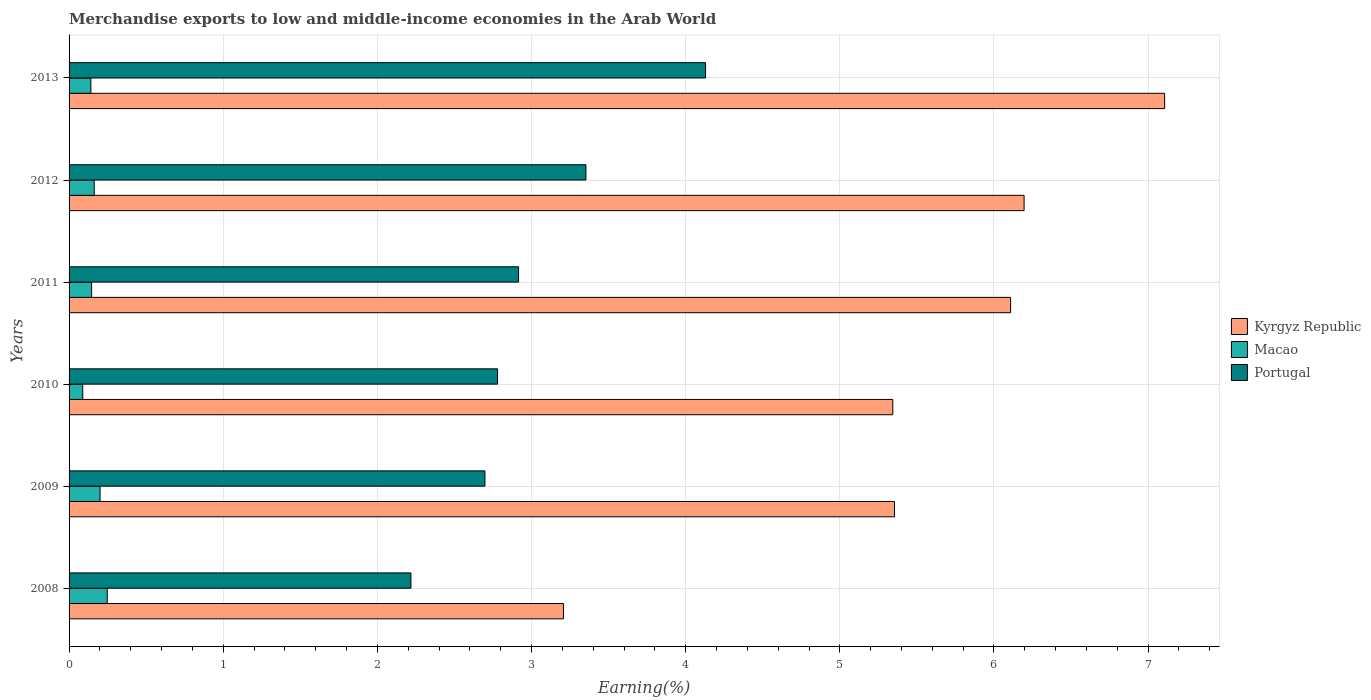How many different coloured bars are there?
Your answer should be compact. 3. How many groups of bars are there?
Keep it short and to the point. 6. Are the number of bars per tick equal to the number of legend labels?
Provide a short and direct response. Yes. Are the number of bars on each tick of the Y-axis equal?
Provide a short and direct response. Yes. How many bars are there on the 5th tick from the top?
Give a very brief answer. 3. How many bars are there on the 4th tick from the bottom?
Provide a succinct answer. 3. What is the label of the 3rd group of bars from the top?
Give a very brief answer. 2011. What is the percentage of amount earned from merchandise exports in Macao in 2008?
Ensure brevity in your answer.  0.25. Across all years, what is the maximum percentage of amount earned from merchandise exports in Macao?
Your answer should be very brief. 0.25. Across all years, what is the minimum percentage of amount earned from merchandise exports in Kyrgyz Republic?
Offer a terse response. 3.21. In which year was the percentage of amount earned from merchandise exports in Portugal maximum?
Give a very brief answer. 2013. What is the total percentage of amount earned from merchandise exports in Kyrgyz Republic in the graph?
Provide a succinct answer. 33.32. What is the difference between the percentage of amount earned from merchandise exports in Portugal in 2008 and that in 2011?
Give a very brief answer. -0.7. What is the difference between the percentage of amount earned from merchandise exports in Kyrgyz Republic in 2010 and the percentage of amount earned from merchandise exports in Portugal in 2009?
Keep it short and to the point. 2.65. What is the average percentage of amount earned from merchandise exports in Macao per year?
Offer a very short reply. 0.16. In the year 2013, what is the difference between the percentage of amount earned from merchandise exports in Macao and percentage of amount earned from merchandise exports in Kyrgyz Republic?
Provide a short and direct response. -6.97. In how many years, is the percentage of amount earned from merchandise exports in Macao greater than 4.6 %?
Your answer should be very brief. 0. What is the ratio of the percentage of amount earned from merchandise exports in Macao in 2011 to that in 2012?
Keep it short and to the point. 0.9. Is the percentage of amount earned from merchandise exports in Kyrgyz Republic in 2010 less than that in 2012?
Offer a terse response. Yes. What is the difference between the highest and the second highest percentage of amount earned from merchandise exports in Macao?
Offer a terse response. 0.05. What is the difference between the highest and the lowest percentage of amount earned from merchandise exports in Macao?
Keep it short and to the point. 0.16. In how many years, is the percentage of amount earned from merchandise exports in Macao greater than the average percentage of amount earned from merchandise exports in Macao taken over all years?
Offer a terse response. 2. What does the 1st bar from the top in 2010 represents?
Make the answer very short. Portugal. Is it the case that in every year, the sum of the percentage of amount earned from merchandise exports in Portugal and percentage of amount earned from merchandise exports in Kyrgyz Republic is greater than the percentage of amount earned from merchandise exports in Macao?
Ensure brevity in your answer.  Yes. How many bars are there?
Offer a very short reply. 18. Are all the bars in the graph horizontal?
Your answer should be very brief. Yes. How many years are there in the graph?
Your response must be concise. 6. Does the graph contain any zero values?
Your response must be concise. No. Does the graph contain grids?
Your answer should be very brief. Yes. Where does the legend appear in the graph?
Offer a terse response. Center right. How many legend labels are there?
Your answer should be compact. 3. What is the title of the graph?
Offer a terse response. Merchandise exports to low and middle-income economies in the Arab World. What is the label or title of the X-axis?
Provide a short and direct response. Earning(%). What is the label or title of the Y-axis?
Your answer should be compact. Years. What is the Earning(%) of Kyrgyz Republic in 2008?
Provide a succinct answer. 3.21. What is the Earning(%) of Macao in 2008?
Offer a very short reply. 0.25. What is the Earning(%) of Portugal in 2008?
Provide a short and direct response. 2.22. What is the Earning(%) in Kyrgyz Republic in 2009?
Ensure brevity in your answer.  5.35. What is the Earning(%) of Macao in 2009?
Provide a succinct answer. 0.2. What is the Earning(%) in Portugal in 2009?
Ensure brevity in your answer.  2.7. What is the Earning(%) of Kyrgyz Republic in 2010?
Your answer should be very brief. 5.34. What is the Earning(%) of Macao in 2010?
Provide a succinct answer. 0.09. What is the Earning(%) of Portugal in 2010?
Your answer should be very brief. 2.78. What is the Earning(%) in Kyrgyz Republic in 2011?
Your answer should be very brief. 6.11. What is the Earning(%) of Macao in 2011?
Your answer should be compact. 0.15. What is the Earning(%) in Portugal in 2011?
Give a very brief answer. 2.92. What is the Earning(%) in Kyrgyz Republic in 2012?
Provide a succinct answer. 6.2. What is the Earning(%) of Macao in 2012?
Ensure brevity in your answer.  0.16. What is the Earning(%) in Portugal in 2012?
Offer a terse response. 3.35. What is the Earning(%) of Kyrgyz Republic in 2013?
Offer a very short reply. 7.11. What is the Earning(%) in Macao in 2013?
Make the answer very short. 0.14. What is the Earning(%) in Portugal in 2013?
Provide a short and direct response. 4.13. Across all years, what is the maximum Earning(%) of Kyrgyz Republic?
Your answer should be compact. 7.11. Across all years, what is the maximum Earning(%) in Macao?
Provide a short and direct response. 0.25. Across all years, what is the maximum Earning(%) in Portugal?
Keep it short and to the point. 4.13. Across all years, what is the minimum Earning(%) in Kyrgyz Republic?
Ensure brevity in your answer.  3.21. Across all years, what is the minimum Earning(%) of Macao?
Give a very brief answer. 0.09. Across all years, what is the minimum Earning(%) of Portugal?
Offer a terse response. 2.22. What is the total Earning(%) in Kyrgyz Republic in the graph?
Offer a terse response. 33.32. What is the total Earning(%) in Macao in the graph?
Make the answer very short. 0.99. What is the total Earning(%) in Portugal in the graph?
Your response must be concise. 18.09. What is the difference between the Earning(%) of Kyrgyz Republic in 2008 and that in 2009?
Give a very brief answer. -2.15. What is the difference between the Earning(%) of Macao in 2008 and that in 2009?
Provide a short and direct response. 0.05. What is the difference between the Earning(%) in Portugal in 2008 and that in 2009?
Ensure brevity in your answer.  -0.48. What is the difference between the Earning(%) in Kyrgyz Republic in 2008 and that in 2010?
Your answer should be compact. -2.14. What is the difference between the Earning(%) in Macao in 2008 and that in 2010?
Make the answer very short. 0.16. What is the difference between the Earning(%) of Portugal in 2008 and that in 2010?
Make the answer very short. -0.56. What is the difference between the Earning(%) of Kyrgyz Republic in 2008 and that in 2011?
Offer a very short reply. -2.9. What is the difference between the Earning(%) in Macao in 2008 and that in 2011?
Your answer should be very brief. 0.1. What is the difference between the Earning(%) of Portugal in 2008 and that in 2011?
Provide a short and direct response. -0.7. What is the difference between the Earning(%) of Kyrgyz Republic in 2008 and that in 2012?
Offer a very short reply. -2.99. What is the difference between the Earning(%) in Macao in 2008 and that in 2012?
Offer a very short reply. 0.08. What is the difference between the Earning(%) in Portugal in 2008 and that in 2012?
Provide a short and direct response. -1.14. What is the difference between the Earning(%) in Kyrgyz Republic in 2008 and that in 2013?
Your response must be concise. -3.9. What is the difference between the Earning(%) of Macao in 2008 and that in 2013?
Keep it short and to the point. 0.11. What is the difference between the Earning(%) in Portugal in 2008 and that in 2013?
Provide a succinct answer. -1.91. What is the difference between the Earning(%) of Kyrgyz Republic in 2009 and that in 2010?
Your answer should be compact. 0.01. What is the difference between the Earning(%) in Macao in 2009 and that in 2010?
Ensure brevity in your answer.  0.11. What is the difference between the Earning(%) of Portugal in 2009 and that in 2010?
Offer a very short reply. -0.08. What is the difference between the Earning(%) of Kyrgyz Republic in 2009 and that in 2011?
Provide a short and direct response. -0.75. What is the difference between the Earning(%) in Macao in 2009 and that in 2011?
Ensure brevity in your answer.  0.05. What is the difference between the Earning(%) in Portugal in 2009 and that in 2011?
Ensure brevity in your answer.  -0.22. What is the difference between the Earning(%) of Kyrgyz Republic in 2009 and that in 2012?
Ensure brevity in your answer.  -0.84. What is the difference between the Earning(%) of Macao in 2009 and that in 2012?
Provide a short and direct response. 0.04. What is the difference between the Earning(%) in Portugal in 2009 and that in 2012?
Provide a succinct answer. -0.66. What is the difference between the Earning(%) in Kyrgyz Republic in 2009 and that in 2013?
Your response must be concise. -1.75. What is the difference between the Earning(%) in Macao in 2009 and that in 2013?
Your answer should be compact. 0.06. What is the difference between the Earning(%) in Portugal in 2009 and that in 2013?
Offer a terse response. -1.43. What is the difference between the Earning(%) in Kyrgyz Republic in 2010 and that in 2011?
Your answer should be compact. -0.76. What is the difference between the Earning(%) in Macao in 2010 and that in 2011?
Offer a very short reply. -0.06. What is the difference between the Earning(%) of Portugal in 2010 and that in 2011?
Make the answer very short. -0.14. What is the difference between the Earning(%) in Kyrgyz Republic in 2010 and that in 2012?
Make the answer very short. -0.85. What is the difference between the Earning(%) of Macao in 2010 and that in 2012?
Provide a short and direct response. -0.07. What is the difference between the Earning(%) in Portugal in 2010 and that in 2012?
Ensure brevity in your answer.  -0.57. What is the difference between the Earning(%) in Kyrgyz Republic in 2010 and that in 2013?
Your response must be concise. -1.76. What is the difference between the Earning(%) in Macao in 2010 and that in 2013?
Provide a short and direct response. -0.05. What is the difference between the Earning(%) in Portugal in 2010 and that in 2013?
Keep it short and to the point. -1.35. What is the difference between the Earning(%) of Kyrgyz Republic in 2011 and that in 2012?
Your response must be concise. -0.09. What is the difference between the Earning(%) in Macao in 2011 and that in 2012?
Your response must be concise. -0.02. What is the difference between the Earning(%) in Portugal in 2011 and that in 2012?
Provide a succinct answer. -0.44. What is the difference between the Earning(%) of Kyrgyz Republic in 2011 and that in 2013?
Make the answer very short. -1. What is the difference between the Earning(%) of Macao in 2011 and that in 2013?
Make the answer very short. 0. What is the difference between the Earning(%) of Portugal in 2011 and that in 2013?
Your answer should be very brief. -1.21. What is the difference between the Earning(%) of Kyrgyz Republic in 2012 and that in 2013?
Your response must be concise. -0.91. What is the difference between the Earning(%) of Macao in 2012 and that in 2013?
Your answer should be compact. 0.02. What is the difference between the Earning(%) of Portugal in 2012 and that in 2013?
Make the answer very short. -0.78. What is the difference between the Earning(%) of Kyrgyz Republic in 2008 and the Earning(%) of Macao in 2009?
Your answer should be compact. 3.01. What is the difference between the Earning(%) in Kyrgyz Republic in 2008 and the Earning(%) in Portugal in 2009?
Provide a succinct answer. 0.51. What is the difference between the Earning(%) in Macao in 2008 and the Earning(%) in Portugal in 2009?
Provide a succinct answer. -2.45. What is the difference between the Earning(%) in Kyrgyz Republic in 2008 and the Earning(%) in Macao in 2010?
Ensure brevity in your answer.  3.12. What is the difference between the Earning(%) in Kyrgyz Republic in 2008 and the Earning(%) in Portugal in 2010?
Provide a succinct answer. 0.43. What is the difference between the Earning(%) of Macao in 2008 and the Earning(%) of Portugal in 2010?
Give a very brief answer. -2.53. What is the difference between the Earning(%) in Kyrgyz Republic in 2008 and the Earning(%) in Macao in 2011?
Provide a short and direct response. 3.06. What is the difference between the Earning(%) of Kyrgyz Republic in 2008 and the Earning(%) of Portugal in 2011?
Your answer should be very brief. 0.29. What is the difference between the Earning(%) of Macao in 2008 and the Earning(%) of Portugal in 2011?
Provide a short and direct response. -2.67. What is the difference between the Earning(%) of Kyrgyz Republic in 2008 and the Earning(%) of Macao in 2012?
Offer a very short reply. 3.04. What is the difference between the Earning(%) in Kyrgyz Republic in 2008 and the Earning(%) in Portugal in 2012?
Offer a very short reply. -0.15. What is the difference between the Earning(%) of Macao in 2008 and the Earning(%) of Portugal in 2012?
Your response must be concise. -3.11. What is the difference between the Earning(%) in Kyrgyz Republic in 2008 and the Earning(%) in Macao in 2013?
Give a very brief answer. 3.07. What is the difference between the Earning(%) in Kyrgyz Republic in 2008 and the Earning(%) in Portugal in 2013?
Provide a short and direct response. -0.92. What is the difference between the Earning(%) of Macao in 2008 and the Earning(%) of Portugal in 2013?
Your response must be concise. -3.88. What is the difference between the Earning(%) of Kyrgyz Republic in 2009 and the Earning(%) of Macao in 2010?
Offer a terse response. 5.27. What is the difference between the Earning(%) of Kyrgyz Republic in 2009 and the Earning(%) of Portugal in 2010?
Ensure brevity in your answer.  2.58. What is the difference between the Earning(%) in Macao in 2009 and the Earning(%) in Portugal in 2010?
Ensure brevity in your answer.  -2.58. What is the difference between the Earning(%) of Kyrgyz Republic in 2009 and the Earning(%) of Macao in 2011?
Keep it short and to the point. 5.21. What is the difference between the Earning(%) of Kyrgyz Republic in 2009 and the Earning(%) of Portugal in 2011?
Your answer should be very brief. 2.44. What is the difference between the Earning(%) of Macao in 2009 and the Earning(%) of Portugal in 2011?
Your response must be concise. -2.71. What is the difference between the Earning(%) of Kyrgyz Republic in 2009 and the Earning(%) of Macao in 2012?
Your response must be concise. 5.19. What is the difference between the Earning(%) in Kyrgyz Republic in 2009 and the Earning(%) in Portugal in 2012?
Ensure brevity in your answer.  2. What is the difference between the Earning(%) in Macao in 2009 and the Earning(%) in Portugal in 2012?
Offer a terse response. -3.15. What is the difference between the Earning(%) of Kyrgyz Republic in 2009 and the Earning(%) of Macao in 2013?
Make the answer very short. 5.21. What is the difference between the Earning(%) in Kyrgyz Republic in 2009 and the Earning(%) in Portugal in 2013?
Make the answer very short. 1.23. What is the difference between the Earning(%) in Macao in 2009 and the Earning(%) in Portugal in 2013?
Offer a very short reply. -3.93. What is the difference between the Earning(%) of Kyrgyz Republic in 2010 and the Earning(%) of Macao in 2011?
Provide a short and direct response. 5.2. What is the difference between the Earning(%) of Kyrgyz Republic in 2010 and the Earning(%) of Portugal in 2011?
Offer a very short reply. 2.43. What is the difference between the Earning(%) in Macao in 2010 and the Earning(%) in Portugal in 2011?
Ensure brevity in your answer.  -2.83. What is the difference between the Earning(%) in Kyrgyz Republic in 2010 and the Earning(%) in Macao in 2012?
Ensure brevity in your answer.  5.18. What is the difference between the Earning(%) of Kyrgyz Republic in 2010 and the Earning(%) of Portugal in 2012?
Provide a succinct answer. 1.99. What is the difference between the Earning(%) of Macao in 2010 and the Earning(%) of Portugal in 2012?
Offer a very short reply. -3.26. What is the difference between the Earning(%) in Kyrgyz Republic in 2010 and the Earning(%) in Macao in 2013?
Provide a short and direct response. 5.2. What is the difference between the Earning(%) of Kyrgyz Republic in 2010 and the Earning(%) of Portugal in 2013?
Your answer should be very brief. 1.21. What is the difference between the Earning(%) in Macao in 2010 and the Earning(%) in Portugal in 2013?
Ensure brevity in your answer.  -4.04. What is the difference between the Earning(%) in Kyrgyz Republic in 2011 and the Earning(%) in Macao in 2012?
Offer a terse response. 5.94. What is the difference between the Earning(%) in Kyrgyz Republic in 2011 and the Earning(%) in Portugal in 2012?
Offer a very short reply. 2.75. What is the difference between the Earning(%) of Macao in 2011 and the Earning(%) of Portugal in 2012?
Make the answer very short. -3.21. What is the difference between the Earning(%) in Kyrgyz Republic in 2011 and the Earning(%) in Macao in 2013?
Provide a short and direct response. 5.97. What is the difference between the Earning(%) in Kyrgyz Republic in 2011 and the Earning(%) in Portugal in 2013?
Provide a succinct answer. 1.98. What is the difference between the Earning(%) of Macao in 2011 and the Earning(%) of Portugal in 2013?
Offer a very short reply. -3.98. What is the difference between the Earning(%) of Kyrgyz Republic in 2012 and the Earning(%) of Macao in 2013?
Keep it short and to the point. 6.05. What is the difference between the Earning(%) of Kyrgyz Republic in 2012 and the Earning(%) of Portugal in 2013?
Ensure brevity in your answer.  2.07. What is the difference between the Earning(%) in Macao in 2012 and the Earning(%) in Portugal in 2013?
Offer a terse response. -3.97. What is the average Earning(%) of Kyrgyz Republic per year?
Keep it short and to the point. 5.55. What is the average Earning(%) in Macao per year?
Your response must be concise. 0.16. What is the average Earning(%) of Portugal per year?
Offer a very short reply. 3.02. In the year 2008, what is the difference between the Earning(%) of Kyrgyz Republic and Earning(%) of Macao?
Your response must be concise. 2.96. In the year 2008, what is the difference between the Earning(%) in Kyrgyz Republic and Earning(%) in Portugal?
Give a very brief answer. 0.99. In the year 2008, what is the difference between the Earning(%) of Macao and Earning(%) of Portugal?
Offer a very short reply. -1.97. In the year 2009, what is the difference between the Earning(%) of Kyrgyz Republic and Earning(%) of Macao?
Your response must be concise. 5.15. In the year 2009, what is the difference between the Earning(%) of Kyrgyz Republic and Earning(%) of Portugal?
Provide a short and direct response. 2.66. In the year 2009, what is the difference between the Earning(%) of Macao and Earning(%) of Portugal?
Offer a very short reply. -2.5. In the year 2010, what is the difference between the Earning(%) of Kyrgyz Republic and Earning(%) of Macao?
Provide a succinct answer. 5.25. In the year 2010, what is the difference between the Earning(%) in Kyrgyz Republic and Earning(%) in Portugal?
Ensure brevity in your answer.  2.56. In the year 2010, what is the difference between the Earning(%) in Macao and Earning(%) in Portugal?
Provide a succinct answer. -2.69. In the year 2011, what is the difference between the Earning(%) of Kyrgyz Republic and Earning(%) of Macao?
Provide a short and direct response. 5.96. In the year 2011, what is the difference between the Earning(%) in Kyrgyz Republic and Earning(%) in Portugal?
Offer a very short reply. 3.19. In the year 2011, what is the difference between the Earning(%) in Macao and Earning(%) in Portugal?
Provide a short and direct response. -2.77. In the year 2012, what is the difference between the Earning(%) of Kyrgyz Republic and Earning(%) of Macao?
Give a very brief answer. 6.03. In the year 2012, what is the difference between the Earning(%) of Kyrgyz Republic and Earning(%) of Portugal?
Offer a terse response. 2.84. In the year 2012, what is the difference between the Earning(%) of Macao and Earning(%) of Portugal?
Offer a very short reply. -3.19. In the year 2013, what is the difference between the Earning(%) of Kyrgyz Republic and Earning(%) of Macao?
Your response must be concise. 6.97. In the year 2013, what is the difference between the Earning(%) of Kyrgyz Republic and Earning(%) of Portugal?
Keep it short and to the point. 2.98. In the year 2013, what is the difference between the Earning(%) of Macao and Earning(%) of Portugal?
Make the answer very short. -3.99. What is the ratio of the Earning(%) in Kyrgyz Republic in 2008 to that in 2009?
Provide a succinct answer. 0.6. What is the ratio of the Earning(%) in Macao in 2008 to that in 2009?
Give a very brief answer. 1.23. What is the ratio of the Earning(%) in Portugal in 2008 to that in 2009?
Your answer should be very brief. 0.82. What is the ratio of the Earning(%) in Kyrgyz Republic in 2008 to that in 2010?
Your answer should be compact. 0.6. What is the ratio of the Earning(%) of Macao in 2008 to that in 2010?
Your answer should be very brief. 2.79. What is the ratio of the Earning(%) in Portugal in 2008 to that in 2010?
Provide a short and direct response. 0.8. What is the ratio of the Earning(%) in Kyrgyz Republic in 2008 to that in 2011?
Ensure brevity in your answer.  0.53. What is the ratio of the Earning(%) in Macao in 2008 to that in 2011?
Ensure brevity in your answer.  1.69. What is the ratio of the Earning(%) of Portugal in 2008 to that in 2011?
Offer a terse response. 0.76. What is the ratio of the Earning(%) in Kyrgyz Republic in 2008 to that in 2012?
Offer a terse response. 0.52. What is the ratio of the Earning(%) in Macao in 2008 to that in 2012?
Your response must be concise. 1.52. What is the ratio of the Earning(%) in Portugal in 2008 to that in 2012?
Your answer should be very brief. 0.66. What is the ratio of the Earning(%) of Kyrgyz Republic in 2008 to that in 2013?
Keep it short and to the point. 0.45. What is the ratio of the Earning(%) in Macao in 2008 to that in 2013?
Keep it short and to the point. 1.75. What is the ratio of the Earning(%) of Portugal in 2008 to that in 2013?
Your answer should be compact. 0.54. What is the ratio of the Earning(%) in Kyrgyz Republic in 2009 to that in 2010?
Ensure brevity in your answer.  1. What is the ratio of the Earning(%) in Macao in 2009 to that in 2010?
Ensure brevity in your answer.  2.27. What is the ratio of the Earning(%) in Portugal in 2009 to that in 2010?
Ensure brevity in your answer.  0.97. What is the ratio of the Earning(%) in Kyrgyz Republic in 2009 to that in 2011?
Ensure brevity in your answer.  0.88. What is the ratio of the Earning(%) in Macao in 2009 to that in 2011?
Provide a succinct answer. 1.38. What is the ratio of the Earning(%) of Portugal in 2009 to that in 2011?
Your answer should be very brief. 0.93. What is the ratio of the Earning(%) of Kyrgyz Republic in 2009 to that in 2012?
Offer a terse response. 0.86. What is the ratio of the Earning(%) of Macao in 2009 to that in 2012?
Your answer should be very brief. 1.23. What is the ratio of the Earning(%) of Portugal in 2009 to that in 2012?
Ensure brevity in your answer.  0.8. What is the ratio of the Earning(%) of Kyrgyz Republic in 2009 to that in 2013?
Your answer should be very brief. 0.75. What is the ratio of the Earning(%) in Macao in 2009 to that in 2013?
Offer a very short reply. 1.42. What is the ratio of the Earning(%) of Portugal in 2009 to that in 2013?
Offer a terse response. 0.65. What is the ratio of the Earning(%) in Kyrgyz Republic in 2010 to that in 2011?
Make the answer very short. 0.87. What is the ratio of the Earning(%) in Macao in 2010 to that in 2011?
Your answer should be compact. 0.61. What is the ratio of the Earning(%) in Portugal in 2010 to that in 2011?
Your answer should be very brief. 0.95. What is the ratio of the Earning(%) in Kyrgyz Republic in 2010 to that in 2012?
Your answer should be compact. 0.86. What is the ratio of the Earning(%) of Macao in 2010 to that in 2012?
Provide a succinct answer. 0.54. What is the ratio of the Earning(%) of Portugal in 2010 to that in 2012?
Ensure brevity in your answer.  0.83. What is the ratio of the Earning(%) in Kyrgyz Republic in 2010 to that in 2013?
Keep it short and to the point. 0.75. What is the ratio of the Earning(%) in Macao in 2010 to that in 2013?
Your answer should be compact. 0.63. What is the ratio of the Earning(%) of Portugal in 2010 to that in 2013?
Give a very brief answer. 0.67. What is the ratio of the Earning(%) in Kyrgyz Republic in 2011 to that in 2012?
Your response must be concise. 0.99. What is the ratio of the Earning(%) in Macao in 2011 to that in 2012?
Give a very brief answer. 0.9. What is the ratio of the Earning(%) of Portugal in 2011 to that in 2012?
Give a very brief answer. 0.87. What is the ratio of the Earning(%) in Kyrgyz Republic in 2011 to that in 2013?
Provide a short and direct response. 0.86. What is the ratio of the Earning(%) in Macao in 2011 to that in 2013?
Give a very brief answer. 1.03. What is the ratio of the Earning(%) in Portugal in 2011 to that in 2013?
Offer a terse response. 0.71. What is the ratio of the Earning(%) in Kyrgyz Republic in 2012 to that in 2013?
Give a very brief answer. 0.87. What is the ratio of the Earning(%) in Macao in 2012 to that in 2013?
Ensure brevity in your answer.  1.15. What is the ratio of the Earning(%) in Portugal in 2012 to that in 2013?
Ensure brevity in your answer.  0.81. What is the difference between the highest and the second highest Earning(%) in Kyrgyz Republic?
Give a very brief answer. 0.91. What is the difference between the highest and the second highest Earning(%) in Macao?
Provide a succinct answer. 0.05. What is the difference between the highest and the second highest Earning(%) of Portugal?
Provide a short and direct response. 0.78. What is the difference between the highest and the lowest Earning(%) of Kyrgyz Republic?
Provide a short and direct response. 3.9. What is the difference between the highest and the lowest Earning(%) in Macao?
Give a very brief answer. 0.16. What is the difference between the highest and the lowest Earning(%) of Portugal?
Offer a terse response. 1.91. 